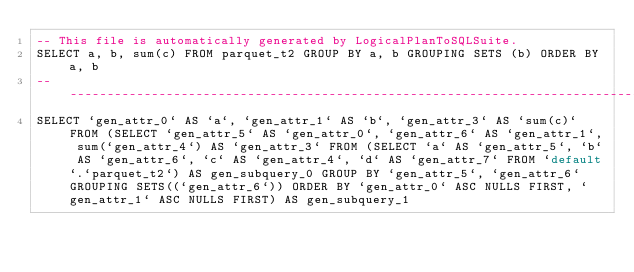Convert code to text. <code><loc_0><loc_0><loc_500><loc_500><_SQL_>-- This file is automatically generated by LogicalPlanToSQLSuite.
SELECT a, b, sum(c) FROM parquet_t2 GROUP BY a, b GROUPING SETS (b) ORDER BY a, b
--------------------------------------------------------------------------------
SELECT `gen_attr_0` AS `a`, `gen_attr_1` AS `b`, `gen_attr_3` AS `sum(c)` FROM (SELECT `gen_attr_5` AS `gen_attr_0`, `gen_attr_6` AS `gen_attr_1`, sum(`gen_attr_4`) AS `gen_attr_3` FROM (SELECT `a` AS `gen_attr_5`, `b` AS `gen_attr_6`, `c` AS `gen_attr_4`, `d` AS `gen_attr_7` FROM `default`.`parquet_t2`) AS gen_subquery_0 GROUP BY `gen_attr_5`, `gen_attr_6` GROUPING SETS((`gen_attr_6`)) ORDER BY `gen_attr_0` ASC NULLS FIRST, `gen_attr_1` ASC NULLS FIRST) AS gen_subquery_1
</code> 